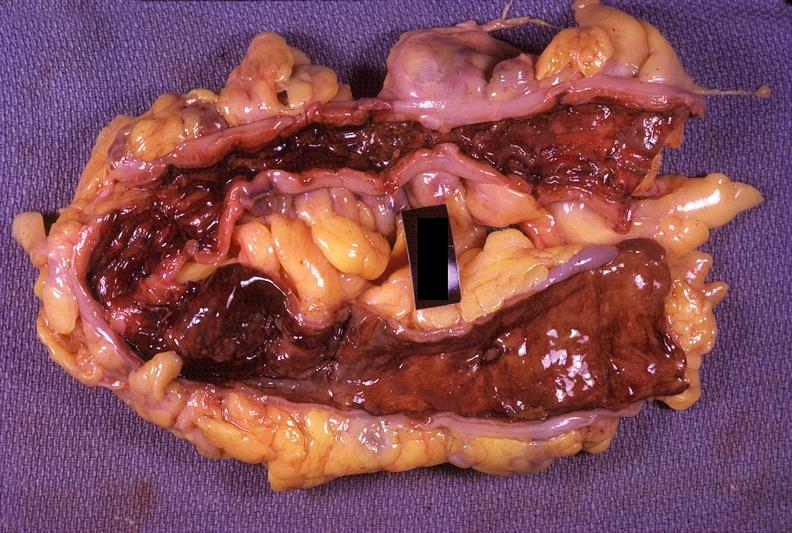does this image show colon, ulcerative colitis?
Answer the question using a single word or phrase. Yes 